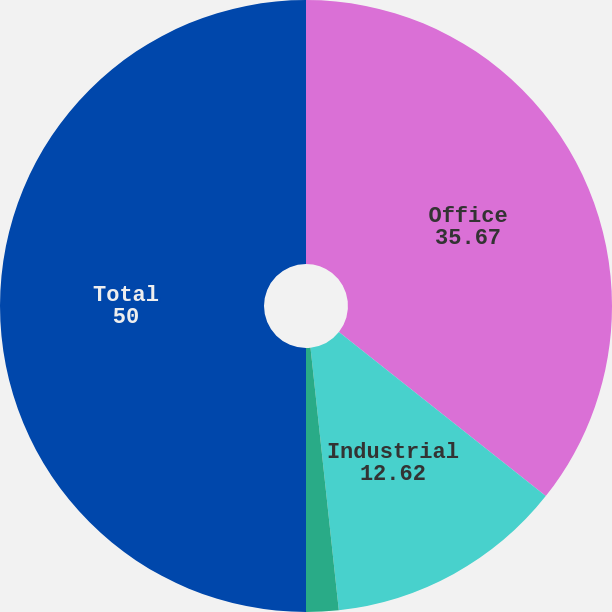<chart> <loc_0><loc_0><loc_500><loc_500><pie_chart><fcel>Office<fcel>Industrial<fcel>Non-reportable segments<fcel>Total<nl><fcel>35.67%<fcel>12.62%<fcel>1.71%<fcel>50.0%<nl></chart> 